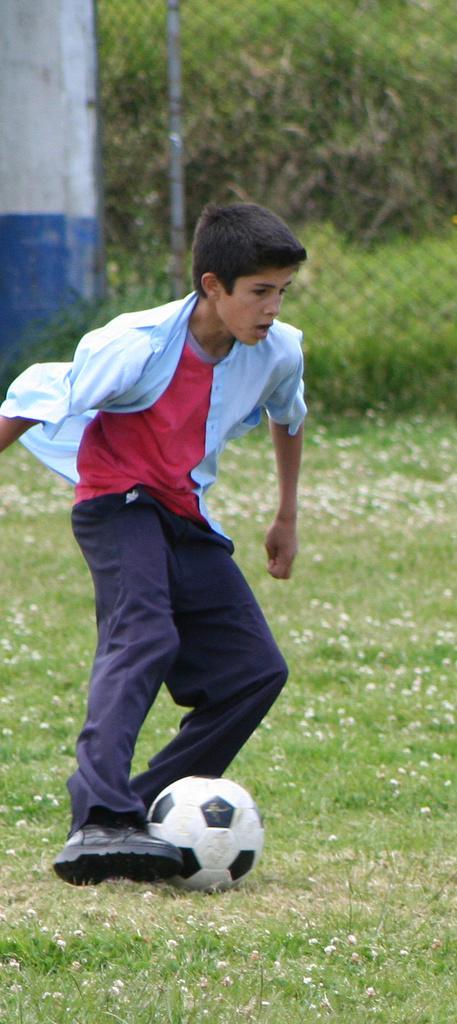Please provide a concise description of this image. In this image I can see the person on the ground. The person is wearing the blue and red color dress. And I can see the ball in-front of the person. In the background I can see the wall, railing and the trees. 